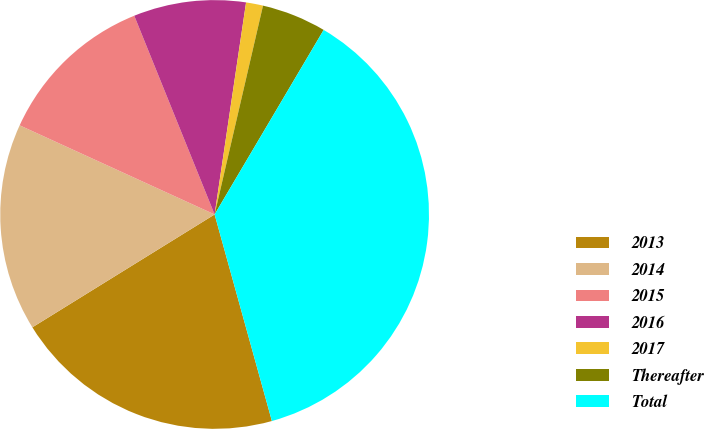Convert chart. <chart><loc_0><loc_0><loc_500><loc_500><pie_chart><fcel>2013<fcel>2014<fcel>2015<fcel>2016<fcel>2017<fcel>Thereafter<fcel>Total<nl><fcel>20.48%<fcel>15.65%<fcel>12.06%<fcel>8.46%<fcel>1.28%<fcel>4.87%<fcel>37.2%<nl></chart> 